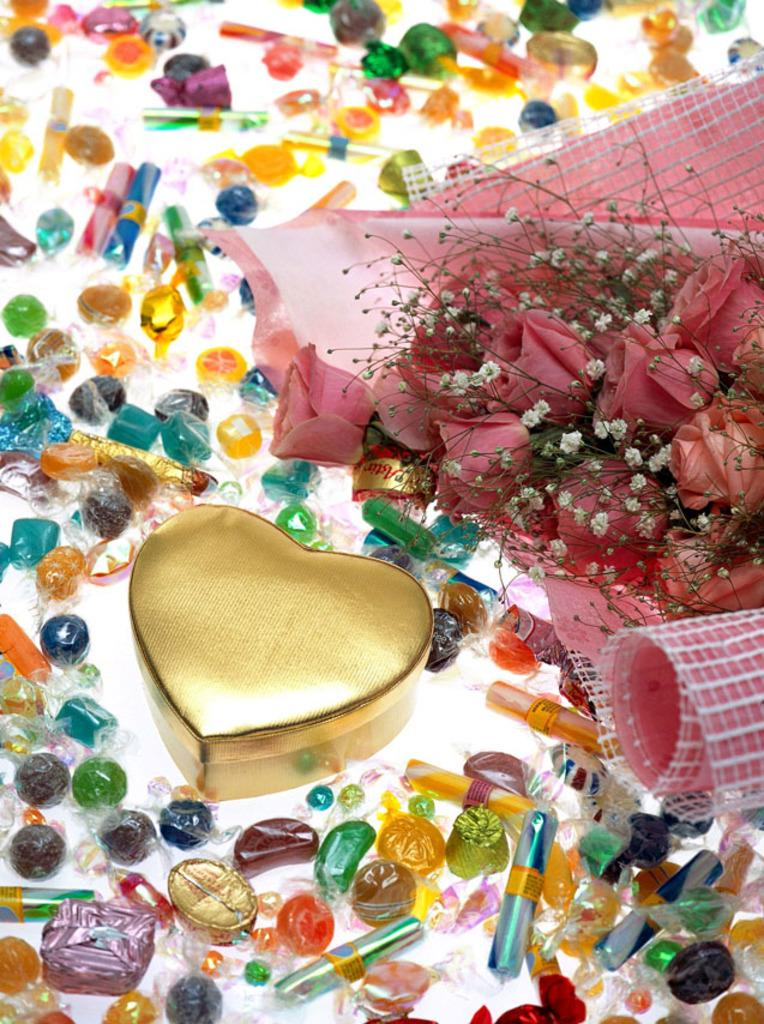What type of sweets can be seen in the image? There are candies in the image. What other object is present in the image besides the candies? There is a bouquet in the image. How many pigs are present in the image? There are no pigs present in the image. What fact can be learned about the candies in the image? The provided facts do not include any specific information about the candies that could be considered a fact. What taste is associated with the candies in the image? The provided facts do not include any specific information about the taste of the candies. 